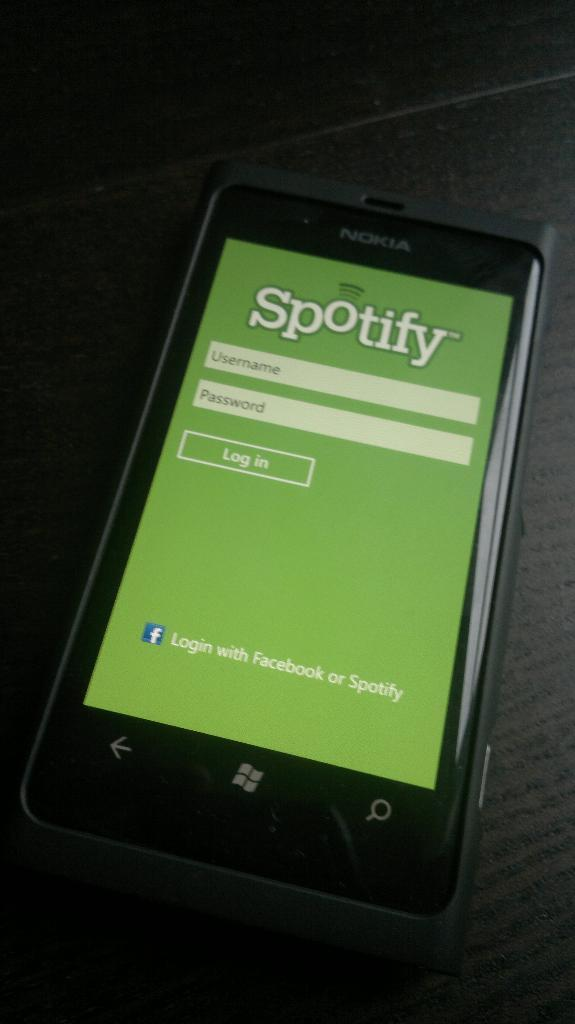<image>
Relay a brief, clear account of the picture shown. the spotify sign in page on a phone screen 